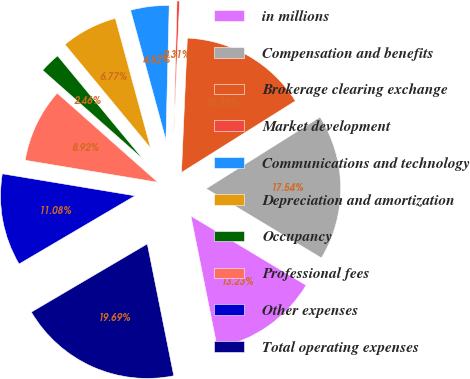Convert chart. <chart><loc_0><loc_0><loc_500><loc_500><pie_chart><fcel>in millions<fcel>Compensation and benefits<fcel>Brokerage clearing exchange<fcel>Market development<fcel>Communications and technology<fcel>Depreciation and amortization<fcel>Occupancy<fcel>Professional fees<fcel>Other expenses<fcel>Total operating expenses<nl><fcel>13.23%<fcel>17.54%<fcel>15.38%<fcel>0.31%<fcel>4.62%<fcel>6.77%<fcel>2.46%<fcel>8.92%<fcel>11.08%<fcel>19.69%<nl></chart> 